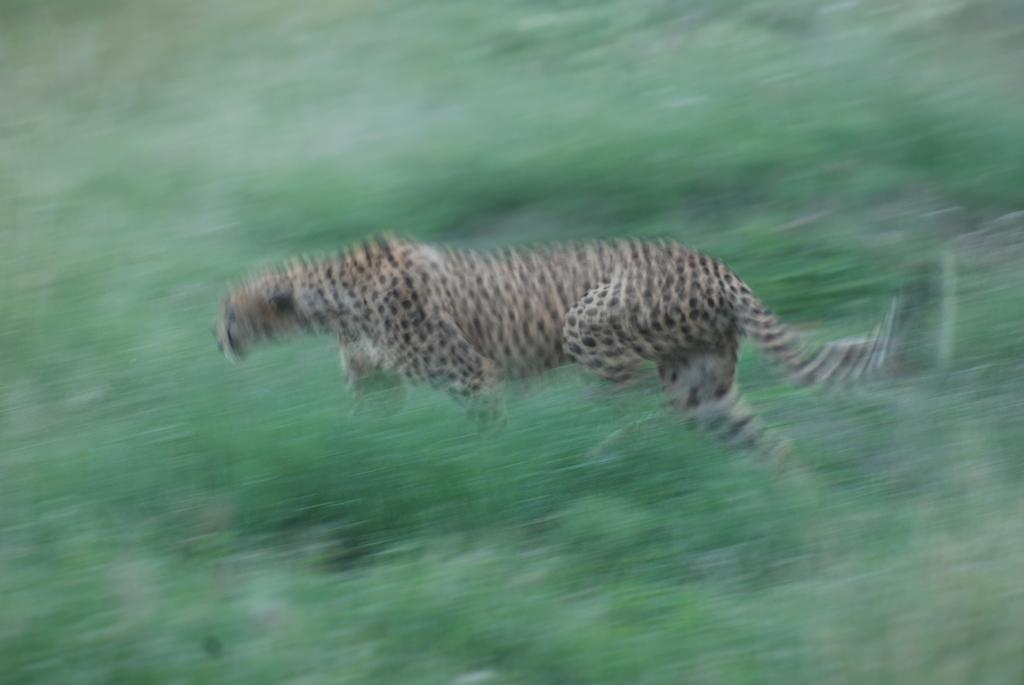What animal is featured in the image? There is a cheetah in the image. What is the cheetah doing in the image? The cheetah is running. Can you describe the quality of the image? The image is blurred. What type of bell can be heard ringing in the image? There is no bell present in the image, and therefore no sound can be heard. 